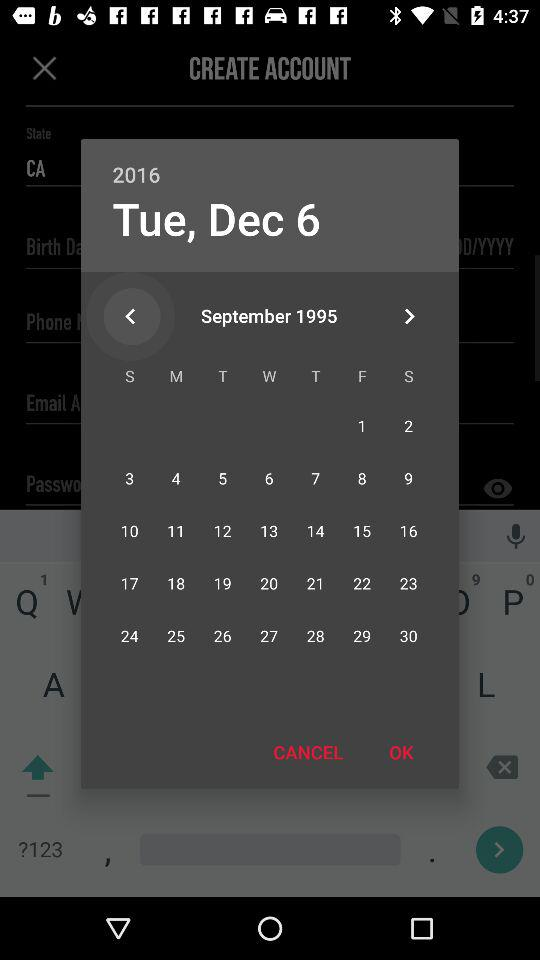Which holiday falls on Tuesday, December 6, 2016?
When the provided information is insufficient, respond with <no answer>. <no answer> 